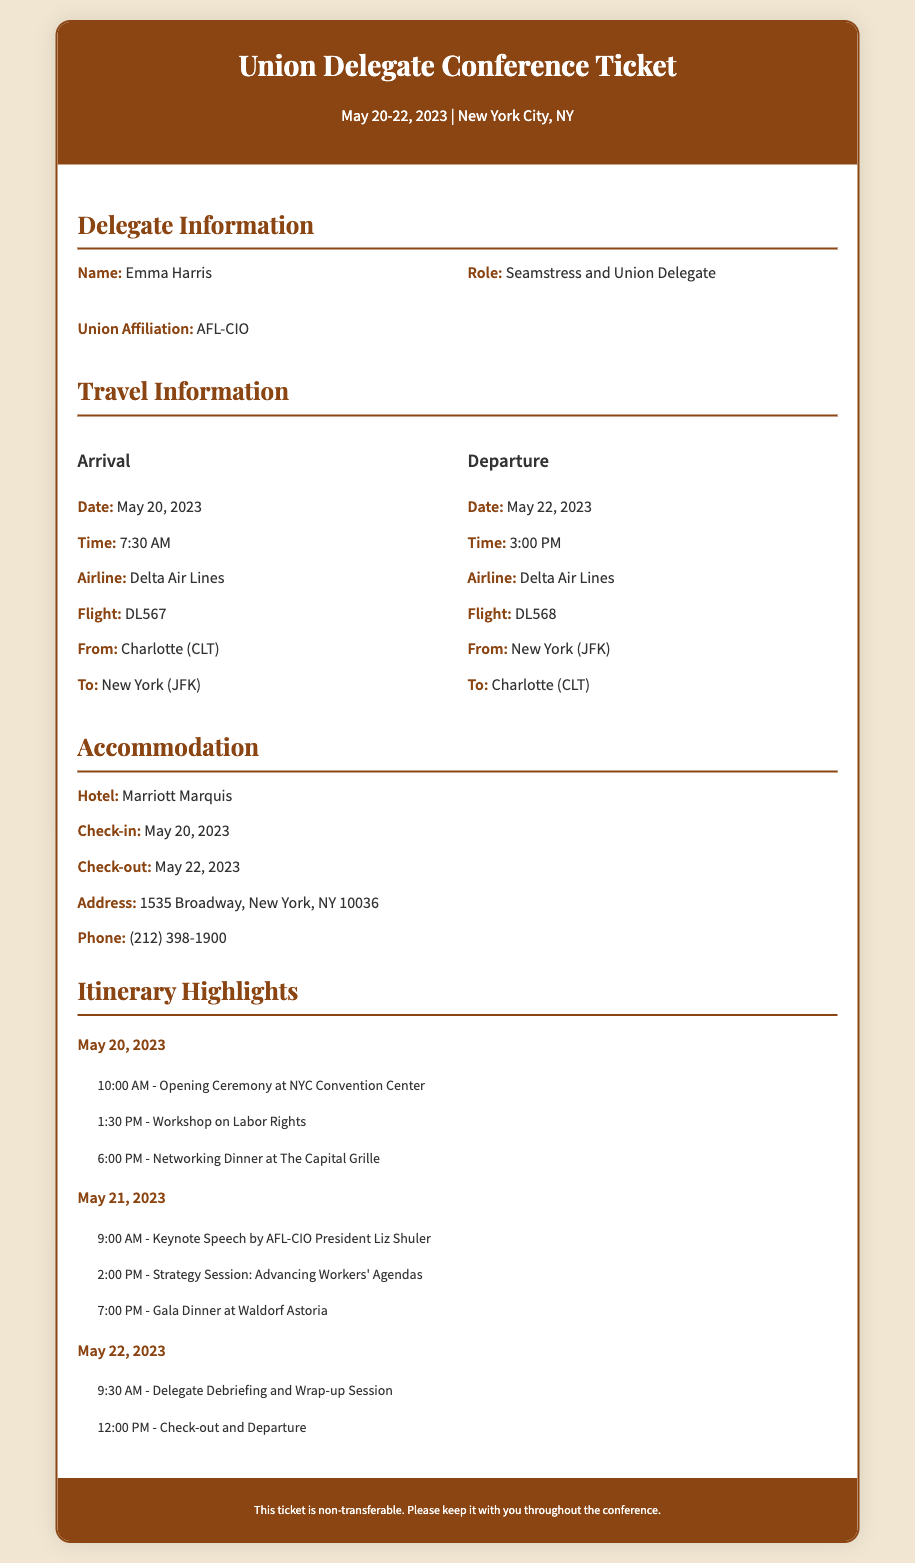What are the dates of the conference? The ticket lists the conference dates as May 20-22, 2023.
Answer: May 20-22, 2023 What is the name of the delegate? The delegate's name is provided in the delegate information section.
Answer: Emma Harris What hotel will the delegate be staying at? The accommodation section specifies the hotel for the stay.
Answer: Marriott Marquis What time is the arrival on May 20, 2023? The travel information section lists the arrival time for that date.
Answer: 7:30 AM What is the address of the hotel? The address is detailed in the accommodation section of the ticket.
Answer: 1535 Broadway, New York, NY 10036 Which airline is the delegate flying with? The travel information mentions the airline used for the flights.
Answer: Delta Air Lines What is the time of the keynote speech on May 21, 2023? The itinerary highlights the time of the keynote speech indicated in the document.
Answer: 9:00 AM What is the check-out date for the hotel? The accommodation section specifies the check-out date for the delegate.
Answer: May 22, 2023 What is the flight number for departure? The travel information section provides the flight number for the return trip.
Answer: DL568 